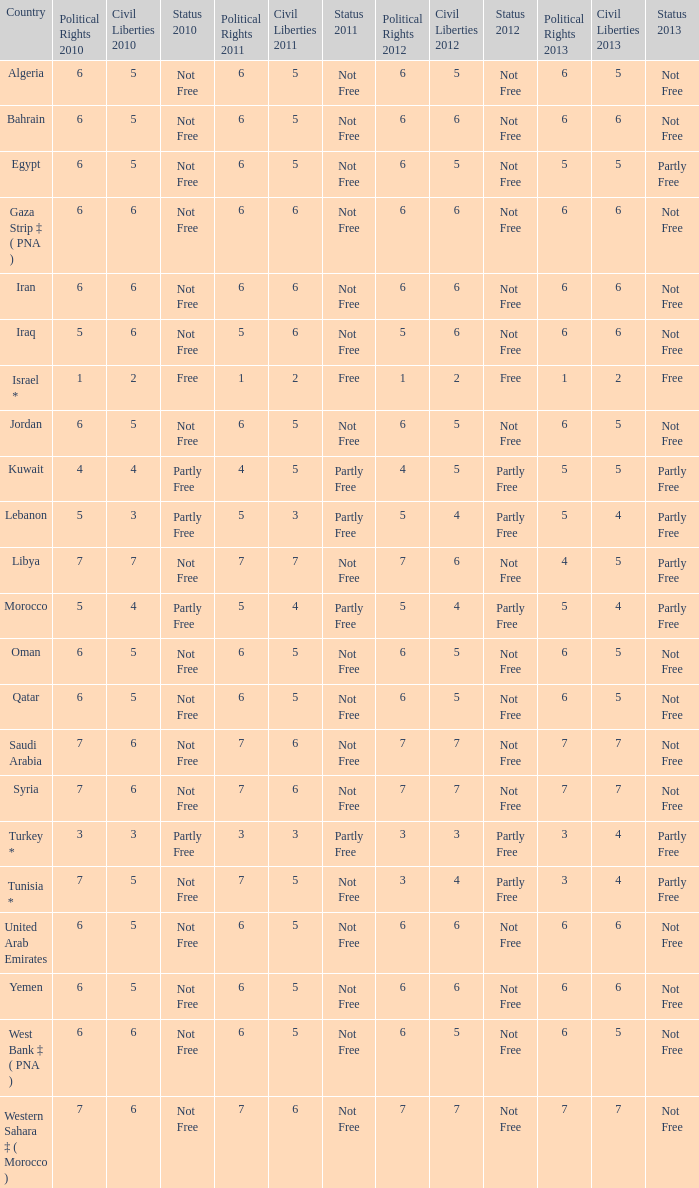Parse the full table. {'header': ['Country', 'Political Rights 2010', 'Civil Liberties 2010', 'Status 2010', 'Political Rights 2011', 'Civil Liberties 2011', 'Status 2011', 'Political Rights 2012', 'Civil Liberties 2012', 'Status 2012', 'Political Rights 2013', 'Civil Liberties 2013', 'Status 2013'], 'rows': [['Algeria', '6', '5', 'Not Free', '6', '5', 'Not Free', '6', '5', 'Not Free', '6', '5', 'Not Free'], ['Bahrain', '6', '5', 'Not Free', '6', '5', 'Not Free', '6', '6', 'Not Free', '6', '6', 'Not Free'], ['Egypt', '6', '5', 'Not Free', '6', '5', 'Not Free', '6', '5', 'Not Free', '5', '5', 'Partly Free'], ['Gaza Strip ‡ ( PNA )', '6', '6', 'Not Free', '6', '6', 'Not Free', '6', '6', 'Not Free', '6', '6', 'Not Free'], ['Iran', '6', '6', 'Not Free', '6', '6', 'Not Free', '6', '6', 'Not Free', '6', '6', 'Not Free'], ['Iraq', '5', '6', 'Not Free', '5', '6', 'Not Free', '5', '6', 'Not Free', '6', '6', 'Not Free'], ['Israel *', '1', '2', 'Free', '1', '2', 'Free', '1', '2', 'Free', '1', '2', 'Free'], ['Jordan', '6', '5', 'Not Free', '6', '5', 'Not Free', '6', '5', 'Not Free', '6', '5', 'Not Free'], ['Kuwait', '4', '4', 'Partly Free', '4', '5', 'Partly Free', '4', '5', 'Partly Free', '5', '5', 'Partly Free'], ['Lebanon', '5', '3', 'Partly Free', '5', '3', 'Partly Free', '5', '4', 'Partly Free', '5', '4', 'Partly Free'], ['Libya', '7', '7', 'Not Free', '7', '7', 'Not Free', '7', '6', 'Not Free', '4', '5', 'Partly Free'], ['Morocco', '5', '4', 'Partly Free', '5', '4', 'Partly Free', '5', '4', 'Partly Free', '5', '4', 'Partly Free'], ['Oman', '6', '5', 'Not Free', '6', '5', 'Not Free', '6', '5', 'Not Free', '6', '5', 'Not Free'], ['Qatar', '6', '5', 'Not Free', '6', '5', 'Not Free', '6', '5', 'Not Free', '6', '5', 'Not Free'], ['Saudi Arabia', '7', '6', 'Not Free', '7', '6', 'Not Free', '7', '7', 'Not Free', '7', '7', 'Not Free'], ['Syria', '7', '6', 'Not Free', '7', '6', 'Not Free', '7', '7', 'Not Free', '7', '7', 'Not Free'], ['Turkey *', '3', '3', 'Partly Free', '3', '3', 'Partly Free', '3', '3', 'Partly Free', '3', '4', 'Partly Free'], ['Tunisia *', '7', '5', 'Not Free', '7', '5', 'Not Free', '3', '4', 'Partly Free', '3', '4', 'Partly Free'], ['United Arab Emirates', '6', '5', 'Not Free', '6', '5', 'Not Free', '6', '6', 'Not Free', '6', '6', 'Not Free'], ['Yemen', '6', '5', 'Not Free', '6', '5', 'Not Free', '6', '6', 'Not Free', '6', '6', 'Not Free'], ['West Bank ‡ ( PNA )', '6', '6', 'Not Free', '6', '5', 'Not Free', '6', '5', 'Not Free', '6', '5', 'Not Free'], ['Western Sahara ‡ ( Morocco )', '7', '6', 'Not Free', '7', '6', 'Not Free', '7', '7', 'Not Free', '7', '7', 'Not Free']]} What is the overall count of civil liberties with 2011 values possessing 2010 political rights values below 3 and 2011 political rights values below 1? 0.0. 